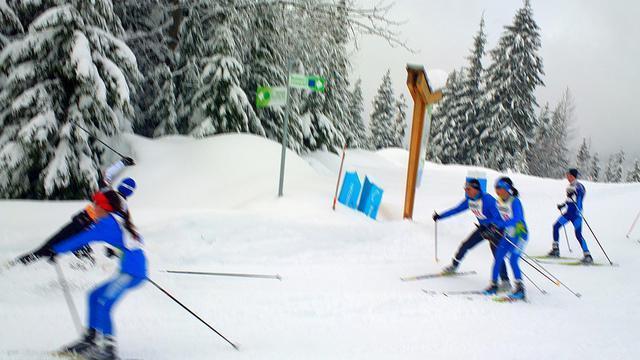How many skiers are in this photo?
Give a very brief answer. 5. How many people can be seen?
Give a very brief answer. 4. 